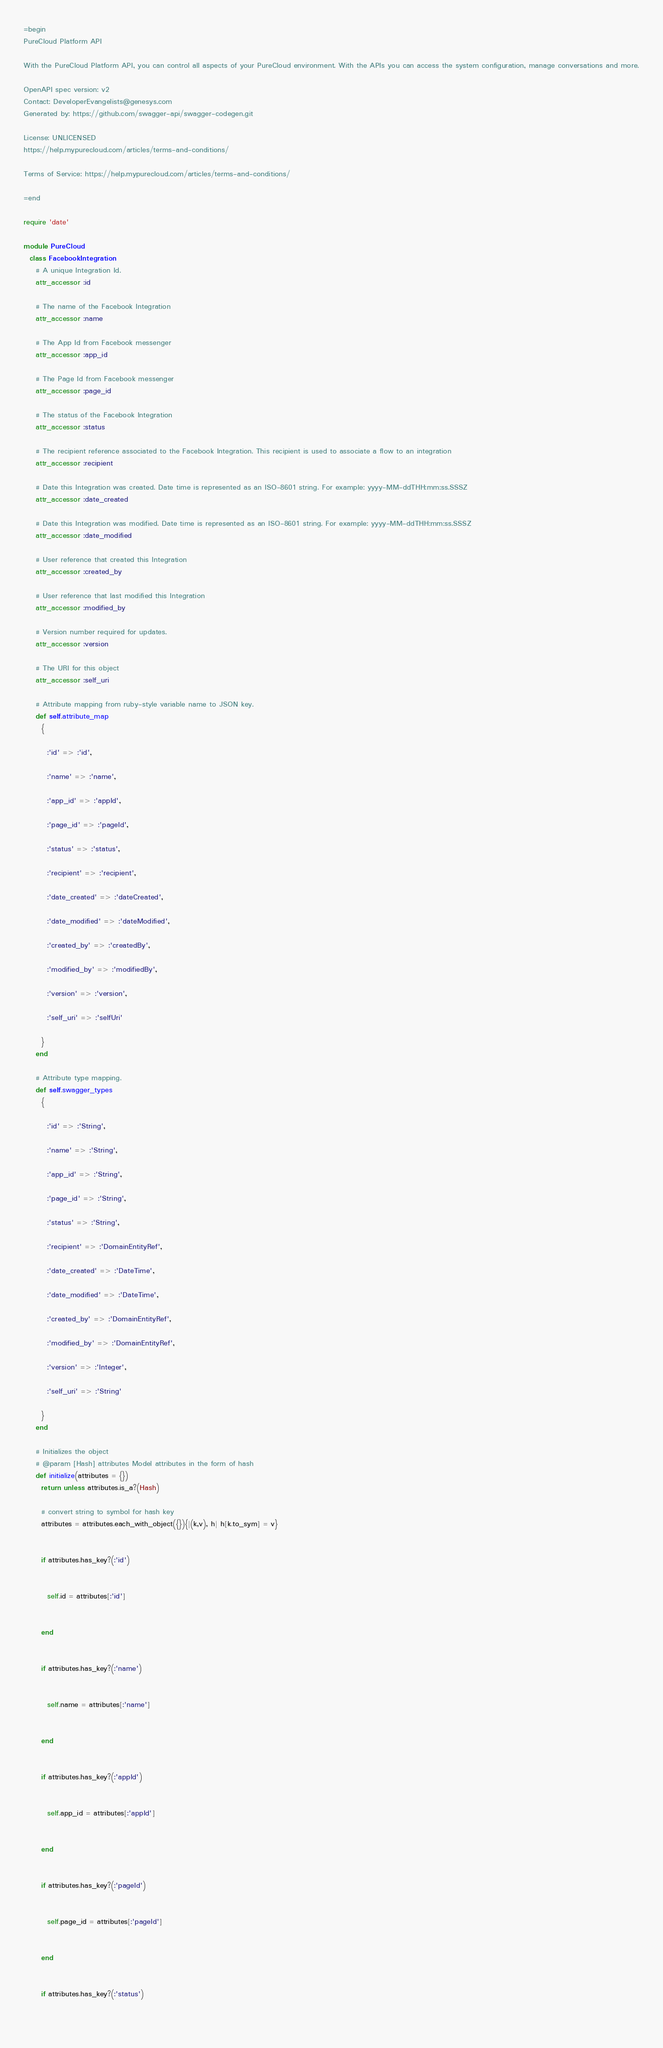<code> <loc_0><loc_0><loc_500><loc_500><_Ruby_>=begin
PureCloud Platform API

With the PureCloud Platform API, you can control all aspects of your PureCloud environment. With the APIs you can access the system configuration, manage conversations and more.

OpenAPI spec version: v2
Contact: DeveloperEvangelists@genesys.com
Generated by: https://github.com/swagger-api/swagger-codegen.git

License: UNLICENSED
https://help.mypurecloud.com/articles/terms-and-conditions/

Terms of Service: https://help.mypurecloud.com/articles/terms-and-conditions/

=end

require 'date'

module PureCloud
  class FacebookIntegration
    # A unique Integration Id.
    attr_accessor :id

    # The name of the Facebook Integration
    attr_accessor :name

    # The App Id from Facebook messenger
    attr_accessor :app_id

    # The Page Id from Facebook messenger
    attr_accessor :page_id

    # The status of the Facebook Integration
    attr_accessor :status

    # The recipient reference associated to the Facebook Integration. This recipient is used to associate a flow to an integration
    attr_accessor :recipient

    # Date this Integration was created. Date time is represented as an ISO-8601 string. For example: yyyy-MM-ddTHH:mm:ss.SSSZ
    attr_accessor :date_created

    # Date this Integration was modified. Date time is represented as an ISO-8601 string. For example: yyyy-MM-ddTHH:mm:ss.SSSZ
    attr_accessor :date_modified

    # User reference that created this Integration
    attr_accessor :created_by

    # User reference that last modified this Integration
    attr_accessor :modified_by

    # Version number required for updates.
    attr_accessor :version

    # The URI for this object
    attr_accessor :self_uri

    # Attribute mapping from ruby-style variable name to JSON key.
    def self.attribute_map
      {
        
        :'id' => :'id',
        
        :'name' => :'name',
        
        :'app_id' => :'appId',
        
        :'page_id' => :'pageId',
        
        :'status' => :'status',
        
        :'recipient' => :'recipient',
        
        :'date_created' => :'dateCreated',
        
        :'date_modified' => :'dateModified',
        
        :'created_by' => :'createdBy',
        
        :'modified_by' => :'modifiedBy',
        
        :'version' => :'version',
        
        :'self_uri' => :'selfUri'
        
      }
    end

    # Attribute type mapping.
    def self.swagger_types
      {
        
        :'id' => :'String',
        
        :'name' => :'String',
        
        :'app_id' => :'String',
        
        :'page_id' => :'String',
        
        :'status' => :'String',
        
        :'recipient' => :'DomainEntityRef',
        
        :'date_created' => :'DateTime',
        
        :'date_modified' => :'DateTime',
        
        :'created_by' => :'DomainEntityRef',
        
        :'modified_by' => :'DomainEntityRef',
        
        :'version' => :'Integer',
        
        :'self_uri' => :'String'
        
      }
    end

    # Initializes the object
    # @param [Hash] attributes Model attributes in the form of hash
    def initialize(attributes = {})
      return unless attributes.is_a?(Hash)

      # convert string to symbol for hash key
      attributes = attributes.each_with_object({}){|(k,v), h| h[k.to_sym] = v}

      
      if attributes.has_key?(:'id')
        
        
        self.id = attributes[:'id']
        
      
      end

      
      if attributes.has_key?(:'name')
        
        
        self.name = attributes[:'name']
        
      
      end

      
      if attributes.has_key?(:'appId')
        
        
        self.app_id = attributes[:'appId']
        
      
      end

      
      if attributes.has_key?(:'pageId')
        
        
        self.page_id = attributes[:'pageId']
        
      
      end

      
      if attributes.has_key?(:'status')
        
        </code> 